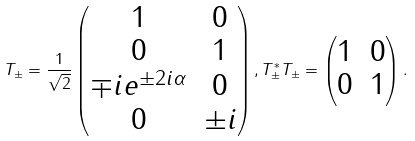<formula> <loc_0><loc_0><loc_500><loc_500>T _ { \pm } = \frac { 1 } { \sqrt { 2 } } \begin{pmatrix} 1 & 0 \\ 0 & 1 \\ \mp i e ^ { \pm 2 i \alpha } & 0 \\ 0 & \pm i \end{pmatrix} , T ^ { * } _ { \pm } T _ { \pm } = \begin{pmatrix} 1 & 0 \\ 0 & 1 \end{pmatrix} .</formula> 